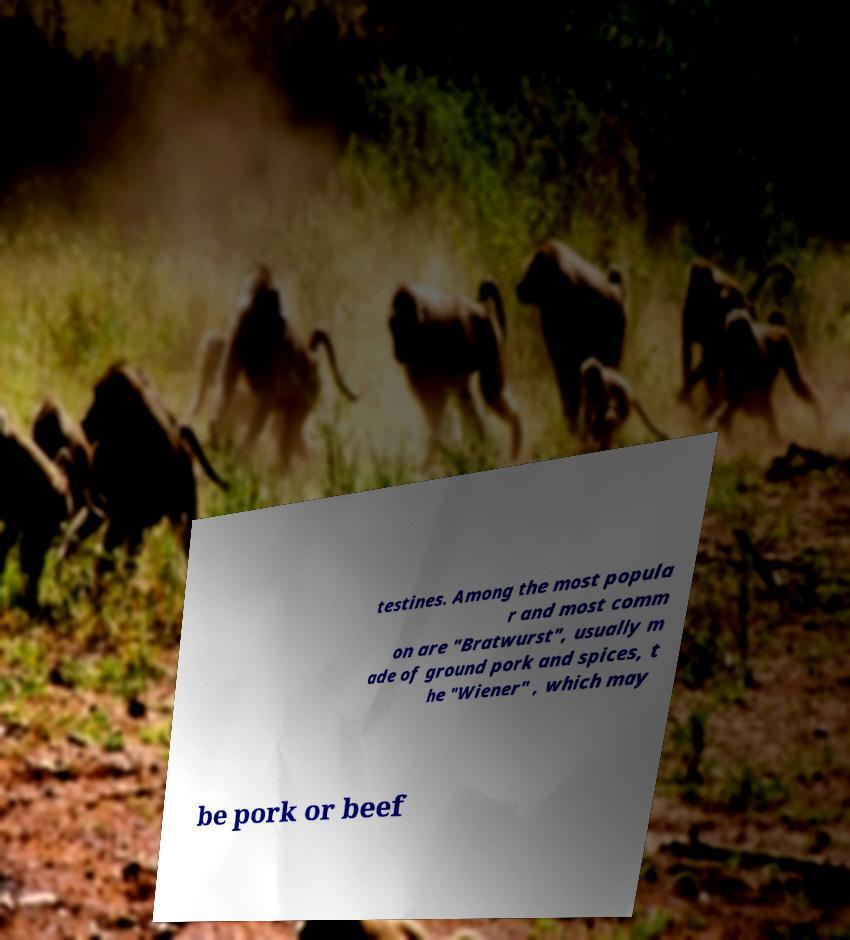What messages or text are displayed in this image? I need them in a readable, typed format. testines. Among the most popula r and most comm on are "Bratwurst", usually m ade of ground pork and spices, t he "Wiener" , which may be pork or beef 